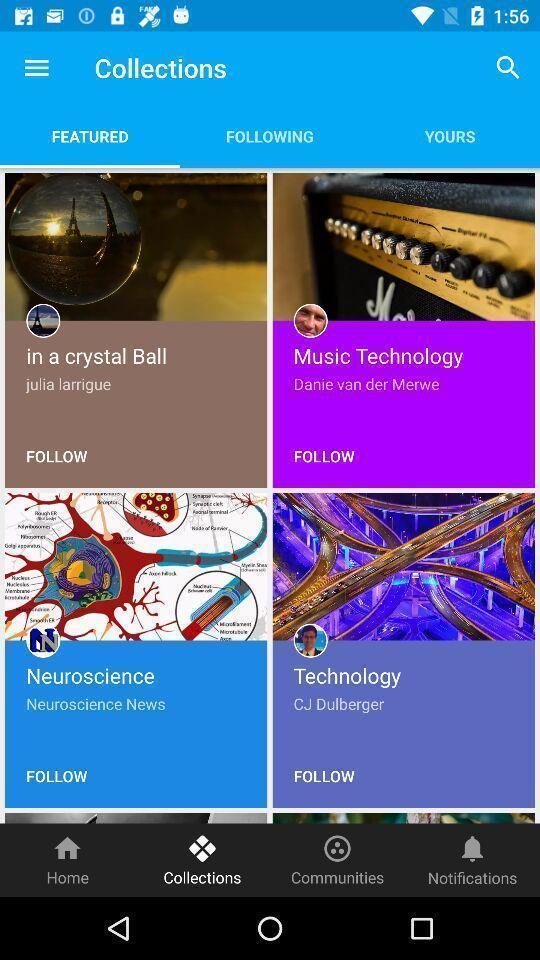Describe this image in words. Page showing list of collections. 